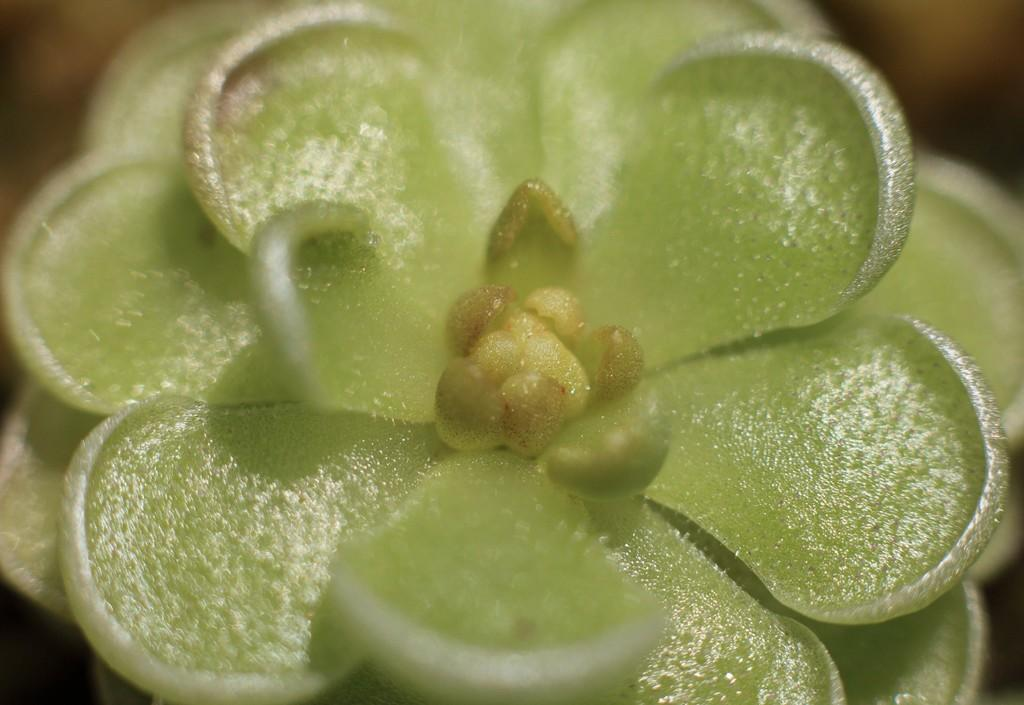What type of flower is in the image? There is a green color flower in the image. What is unique about the petals of the flower? The flower has green petals. What type of cake is being served at the flower's hydrant in the image? There is no cake or hydrant present in the image; it only features a green color flower with green petals. 